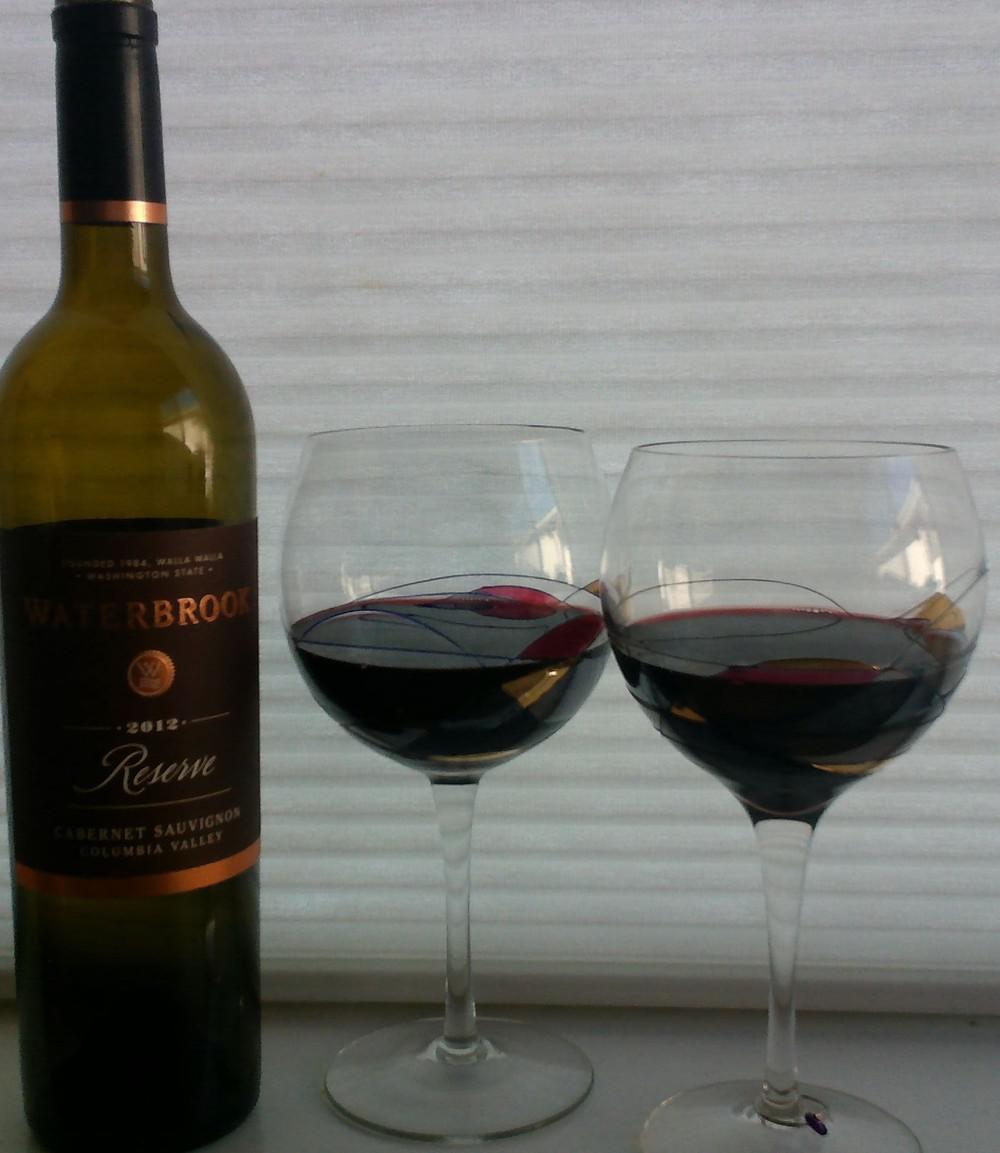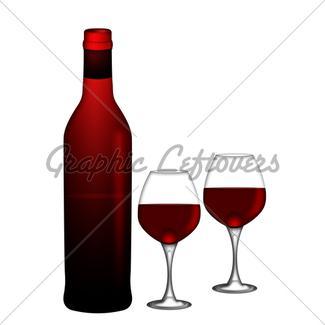The first image is the image on the left, the second image is the image on the right. Assess this claim about the two images: "There is a red bottle of wine with a red top mostly full to the left of a single stemed glass of  red wine filled to the halfway point.". Correct or not? Answer yes or no. No. 